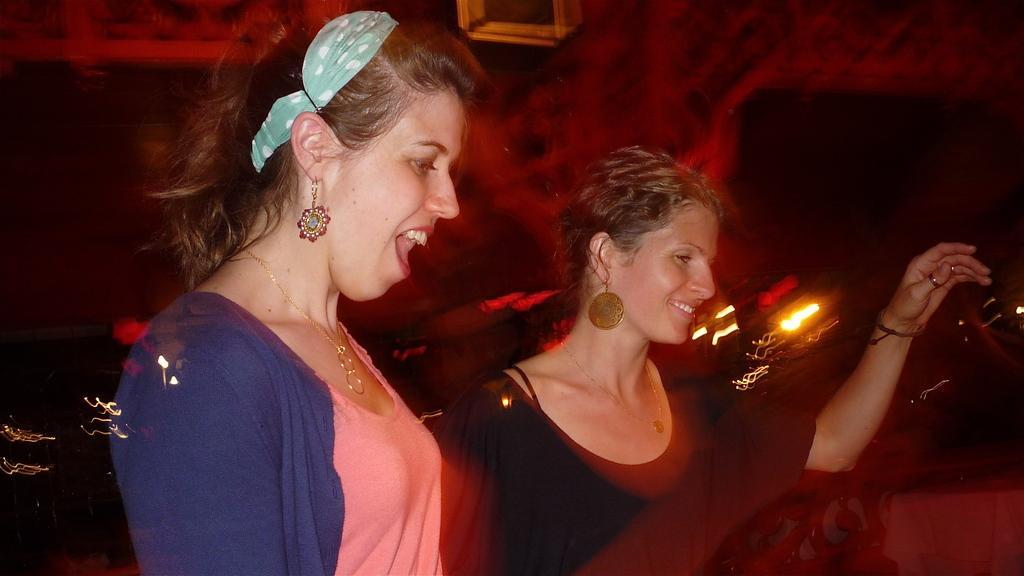Can you describe this image briefly? This image consists of two women. On the right, the woman is wearing a black dress. On the left, the woman is wearing a blue jacket. In the background, we can see a red color along with the light. 